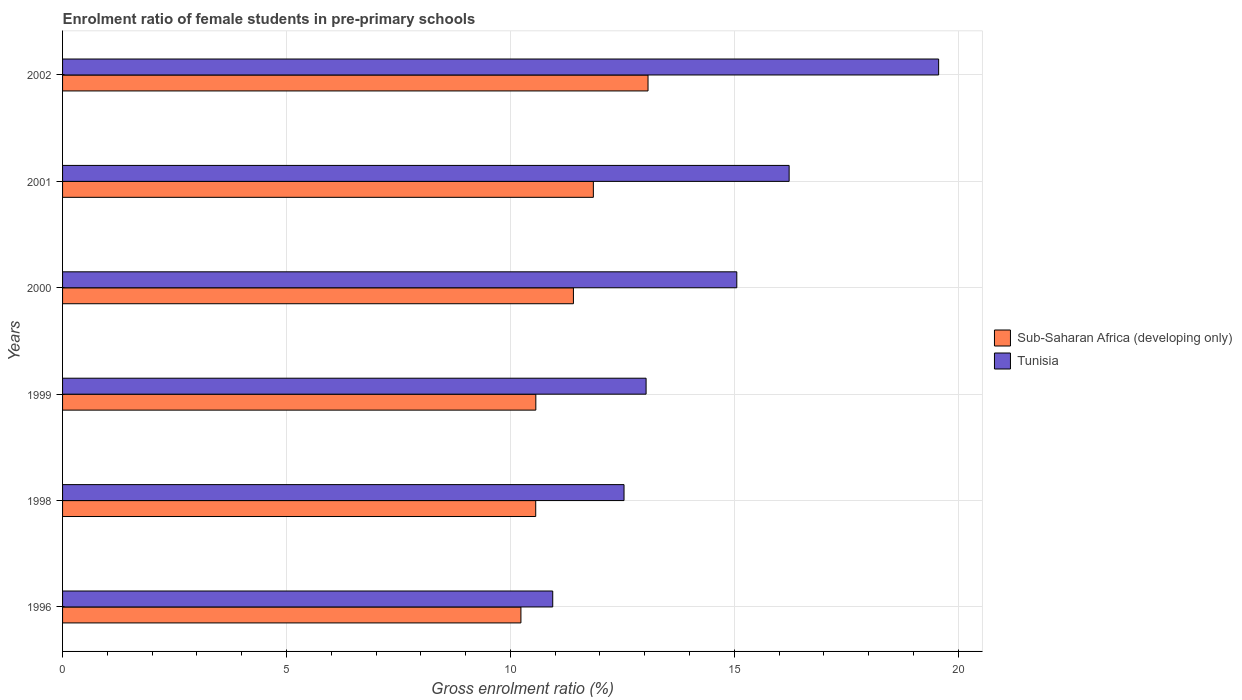How many groups of bars are there?
Offer a terse response. 6. Are the number of bars per tick equal to the number of legend labels?
Provide a succinct answer. Yes. What is the enrolment ratio of female students in pre-primary schools in Sub-Saharan Africa (developing only) in 2002?
Keep it short and to the point. 13.07. Across all years, what is the maximum enrolment ratio of female students in pre-primary schools in Tunisia?
Provide a succinct answer. 19.56. Across all years, what is the minimum enrolment ratio of female students in pre-primary schools in Tunisia?
Your response must be concise. 10.94. In which year was the enrolment ratio of female students in pre-primary schools in Tunisia maximum?
Your answer should be very brief. 2002. In which year was the enrolment ratio of female students in pre-primary schools in Tunisia minimum?
Keep it short and to the point. 1996. What is the total enrolment ratio of female students in pre-primary schools in Tunisia in the graph?
Your answer should be very brief. 87.35. What is the difference between the enrolment ratio of female students in pre-primary schools in Sub-Saharan Africa (developing only) in 1999 and that in 2002?
Offer a terse response. -2.51. What is the difference between the enrolment ratio of female students in pre-primary schools in Tunisia in 1996 and the enrolment ratio of female students in pre-primary schools in Sub-Saharan Africa (developing only) in 2002?
Offer a very short reply. -2.13. What is the average enrolment ratio of female students in pre-primary schools in Sub-Saharan Africa (developing only) per year?
Provide a succinct answer. 11.28. In the year 1996, what is the difference between the enrolment ratio of female students in pre-primary schools in Sub-Saharan Africa (developing only) and enrolment ratio of female students in pre-primary schools in Tunisia?
Keep it short and to the point. -0.71. In how many years, is the enrolment ratio of female students in pre-primary schools in Sub-Saharan Africa (developing only) greater than 15 %?
Provide a short and direct response. 0. What is the ratio of the enrolment ratio of female students in pre-primary schools in Sub-Saharan Africa (developing only) in 1996 to that in 2001?
Provide a short and direct response. 0.86. What is the difference between the highest and the second highest enrolment ratio of female students in pre-primary schools in Sub-Saharan Africa (developing only)?
Offer a very short reply. 1.22. What is the difference between the highest and the lowest enrolment ratio of female students in pre-primary schools in Tunisia?
Give a very brief answer. 8.62. What does the 1st bar from the top in 2000 represents?
Keep it short and to the point. Tunisia. What does the 1st bar from the bottom in 1996 represents?
Keep it short and to the point. Sub-Saharan Africa (developing only). How many bars are there?
Keep it short and to the point. 12. Are all the bars in the graph horizontal?
Ensure brevity in your answer.  Yes. How many years are there in the graph?
Your answer should be compact. 6. What is the difference between two consecutive major ticks on the X-axis?
Offer a terse response. 5. Does the graph contain any zero values?
Offer a very short reply. No. Where does the legend appear in the graph?
Your answer should be compact. Center right. What is the title of the graph?
Make the answer very short. Enrolment ratio of female students in pre-primary schools. Does "Kazakhstan" appear as one of the legend labels in the graph?
Offer a terse response. No. What is the Gross enrolment ratio (%) of Sub-Saharan Africa (developing only) in 1996?
Your response must be concise. 10.23. What is the Gross enrolment ratio (%) of Tunisia in 1996?
Give a very brief answer. 10.94. What is the Gross enrolment ratio (%) in Sub-Saharan Africa (developing only) in 1998?
Ensure brevity in your answer.  10.56. What is the Gross enrolment ratio (%) in Tunisia in 1998?
Your answer should be very brief. 12.54. What is the Gross enrolment ratio (%) of Sub-Saharan Africa (developing only) in 1999?
Make the answer very short. 10.57. What is the Gross enrolment ratio (%) of Tunisia in 1999?
Ensure brevity in your answer.  13.03. What is the Gross enrolment ratio (%) of Sub-Saharan Africa (developing only) in 2000?
Your response must be concise. 11.41. What is the Gross enrolment ratio (%) in Tunisia in 2000?
Provide a short and direct response. 15.05. What is the Gross enrolment ratio (%) in Sub-Saharan Africa (developing only) in 2001?
Make the answer very short. 11.85. What is the Gross enrolment ratio (%) in Tunisia in 2001?
Your answer should be very brief. 16.22. What is the Gross enrolment ratio (%) in Sub-Saharan Africa (developing only) in 2002?
Give a very brief answer. 13.07. What is the Gross enrolment ratio (%) in Tunisia in 2002?
Ensure brevity in your answer.  19.56. Across all years, what is the maximum Gross enrolment ratio (%) of Sub-Saharan Africa (developing only)?
Ensure brevity in your answer.  13.07. Across all years, what is the maximum Gross enrolment ratio (%) of Tunisia?
Offer a terse response. 19.56. Across all years, what is the minimum Gross enrolment ratio (%) of Sub-Saharan Africa (developing only)?
Offer a terse response. 10.23. Across all years, what is the minimum Gross enrolment ratio (%) in Tunisia?
Offer a very short reply. 10.94. What is the total Gross enrolment ratio (%) of Sub-Saharan Africa (developing only) in the graph?
Your answer should be very brief. 67.7. What is the total Gross enrolment ratio (%) of Tunisia in the graph?
Your answer should be very brief. 87.35. What is the difference between the Gross enrolment ratio (%) in Sub-Saharan Africa (developing only) in 1996 and that in 1998?
Your answer should be compact. -0.33. What is the difference between the Gross enrolment ratio (%) in Tunisia in 1996 and that in 1998?
Offer a terse response. -1.59. What is the difference between the Gross enrolment ratio (%) of Sub-Saharan Africa (developing only) in 1996 and that in 1999?
Ensure brevity in your answer.  -0.33. What is the difference between the Gross enrolment ratio (%) in Tunisia in 1996 and that in 1999?
Keep it short and to the point. -2.08. What is the difference between the Gross enrolment ratio (%) of Sub-Saharan Africa (developing only) in 1996 and that in 2000?
Ensure brevity in your answer.  -1.17. What is the difference between the Gross enrolment ratio (%) of Tunisia in 1996 and that in 2000?
Provide a succinct answer. -4.11. What is the difference between the Gross enrolment ratio (%) in Sub-Saharan Africa (developing only) in 1996 and that in 2001?
Provide a succinct answer. -1.62. What is the difference between the Gross enrolment ratio (%) of Tunisia in 1996 and that in 2001?
Provide a short and direct response. -5.28. What is the difference between the Gross enrolment ratio (%) in Sub-Saharan Africa (developing only) in 1996 and that in 2002?
Keep it short and to the point. -2.84. What is the difference between the Gross enrolment ratio (%) in Tunisia in 1996 and that in 2002?
Provide a short and direct response. -8.62. What is the difference between the Gross enrolment ratio (%) of Sub-Saharan Africa (developing only) in 1998 and that in 1999?
Provide a succinct answer. -0. What is the difference between the Gross enrolment ratio (%) of Tunisia in 1998 and that in 1999?
Your answer should be compact. -0.49. What is the difference between the Gross enrolment ratio (%) in Sub-Saharan Africa (developing only) in 1998 and that in 2000?
Your answer should be compact. -0.84. What is the difference between the Gross enrolment ratio (%) in Tunisia in 1998 and that in 2000?
Give a very brief answer. -2.52. What is the difference between the Gross enrolment ratio (%) in Sub-Saharan Africa (developing only) in 1998 and that in 2001?
Make the answer very short. -1.29. What is the difference between the Gross enrolment ratio (%) of Tunisia in 1998 and that in 2001?
Keep it short and to the point. -3.69. What is the difference between the Gross enrolment ratio (%) in Sub-Saharan Africa (developing only) in 1998 and that in 2002?
Offer a terse response. -2.51. What is the difference between the Gross enrolment ratio (%) in Tunisia in 1998 and that in 2002?
Offer a very short reply. -7.02. What is the difference between the Gross enrolment ratio (%) of Sub-Saharan Africa (developing only) in 1999 and that in 2000?
Ensure brevity in your answer.  -0.84. What is the difference between the Gross enrolment ratio (%) in Tunisia in 1999 and that in 2000?
Make the answer very short. -2.03. What is the difference between the Gross enrolment ratio (%) in Sub-Saharan Africa (developing only) in 1999 and that in 2001?
Make the answer very short. -1.28. What is the difference between the Gross enrolment ratio (%) in Tunisia in 1999 and that in 2001?
Offer a terse response. -3.19. What is the difference between the Gross enrolment ratio (%) of Sub-Saharan Africa (developing only) in 1999 and that in 2002?
Ensure brevity in your answer.  -2.51. What is the difference between the Gross enrolment ratio (%) in Tunisia in 1999 and that in 2002?
Provide a short and direct response. -6.53. What is the difference between the Gross enrolment ratio (%) in Sub-Saharan Africa (developing only) in 2000 and that in 2001?
Your response must be concise. -0.45. What is the difference between the Gross enrolment ratio (%) of Tunisia in 2000 and that in 2001?
Give a very brief answer. -1.17. What is the difference between the Gross enrolment ratio (%) in Sub-Saharan Africa (developing only) in 2000 and that in 2002?
Provide a short and direct response. -1.67. What is the difference between the Gross enrolment ratio (%) of Tunisia in 2000 and that in 2002?
Offer a very short reply. -4.51. What is the difference between the Gross enrolment ratio (%) in Sub-Saharan Africa (developing only) in 2001 and that in 2002?
Provide a short and direct response. -1.22. What is the difference between the Gross enrolment ratio (%) in Tunisia in 2001 and that in 2002?
Your response must be concise. -3.34. What is the difference between the Gross enrolment ratio (%) in Sub-Saharan Africa (developing only) in 1996 and the Gross enrolment ratio (%) in Tunisia in 1998?
Offer a very short reply. -2.3. What is the difference between the Gross enrolment ratio (%) of Sub-Saharan Africa (developing only) in 1996 and the Gross enrolment ratio (%) of Tunisia in 1999?
Your answer should be very brief. -2.79. What is the difference between the Gross enrolment ratio (%) in Sub-Saharan Africa (developing only) in 1996 and the Gross enrolment ratio (%) in Tunisia in 2000?
Offer a terse response. -4.82. What is the difference between the Gross enrolment ratio (%) of Sub-Saharan Africa (developing only) in 1996 and the Gross enrolment ratio (%) of Tunisia in 2001?
Offer a very short reply. -5.99. What is the difference between the Gross enrolment ratio (%) of Sub-Saharan Africa (developing only) in 1996 and the Gross enrolment ratio (%) of Tunisia in 2002?
Your response must be concise. -9.33. What is the difference between the Gross enrolment ratio (%) of Sub-Saharan Africa (developing only) in 1998 and the Gross enrolment ratio (%) of Tunisia in 1999?
Provide a succinct answer. -2.46. What is the difference between the Gross enrolment ratio (%) in Sub-Saharan Africa (developing only) in 1998 and the Gross enrolment ratio (%) in Tunisia in 2000?
Make the answer very short. -4.49. What is the difference between the Gross enrolment ratio (%) in Sub-Saharan Africa (developing only) in 1998 and the Gross enrolment ratio (%) in Tunisia in 2001?
Give a very brief answer. -5.66. What is the difference between the Gross enrolment ratio (%) in Sub-Saharan Africa (developing only) in 1998 and the Gross enrolment ratio (%) in Tunisia in 2002?
Your response must be concise. -9. What is the difference between the Gross enrolment ratio (%) of Sub-Saharan Africa (developing only) in 1999 and the Gross enrolment ratio (%) of Tunisia in 2000?
Provide a succinct answer. -4.49. What is the difference between the Gross enrolment ratio (%) in Sub-Saharan Africa (developing only) in 1999 and the Gross enrolment ratio (%) in Tunisia in 2001?
Offer a very short reply. -5.66. What is the difference between the Gross enrolment ratio (%) of Sub-Saharan Africa (developing only) in 1999 and the Gross enrolment ratio (%) of Tunisia in 2002?
Your answer should be compact. -8.99. What is the difference between the Gross enrolment ratio (%) in Sub-Saharan Africa (developing only) in 2000 and the Gross enrolment ratio (%) in Tunisia in 2001?
Ensure brevity in your answer.  -4.82. What is the difference between the Gross enrolment ratio (%) in Sub-Saharan Africa (developing only) in 2000 and the Gross enrolment ratio (%) in Tunisia in 2002?
Give a very brief answer. -8.15. What is the difference between the Gross enrolment ratio (%) of Sub-Saharan Africa (developing only) in 2001 and the Gross enrolment ratio (%) of Tunisia in 2002?
Offer a very short reply. -7.71. What is the average Gross enrolment ratio (%) in Sub-Saharan Africa (developing only) per year?
Offer a terse response. 11.28. What is the average Gross enrolment ratio (%) of Tunisia per year?
Your answer should be very brief. 14.56. In the year 1996, what is the difference between the Gross enrolment ratio (%) in Sub-Saharan Africa (developing only) and Gross enrolment ratio (%) in Tunisia?
Your answer should be very brief. -0.71. In the year 1998, what is the difference between the Gross enrolment ratio (%) of Sub-Saharan Africa (developing only) and Gross enrolment ratio (%) of Tunisia?
Keep it short and to the point. -1.97. In the year 1999, what is the difference between the Gross enrolment ratio (%) of Sub-Saharan Africa (developing only) and Gross enrolment ratio (%) of Tunisia?
Your response must be concise. -2.46. In the year 2000, what is the difference between the Gross enrolment ratio (%) in Sub-Saharan Africa (developing only) and Gross enrolment ratio (%) in Tunisia?
Give a very brief answer. -3.65. In the year 2001, what is the difference between the Gross enrolment ratio (%) of Sub-Saharan Africa (developing only) and Gross enrolment ratio (%) of Tunisia?
Your response must be concise. -4.37. In the year 2002, what is the difference between the Gross enrolment ratio (%) in Sub-Saharan Africa (developing only) and Gross enrolment ratio (%) in Tunisia?
Keep it short and to the point. -6.49. What is the ratio of the Gross enrolment ratio (%) in Sub-Saharan Africa (developing only) in 1996 to that in 1998?
Keep it short and to the point. 0.97. What is the ratio of the Gross enrolment ratio (%) in Tunisia in 1996 to that in 1998?
Offer a very short reply. 0.87. What is the ratio of the Gross enrolment ratio (%) of Sub-Saharan Africa (developing only) in 1996 to that in 1999?
Ensure brevity in your answer.  0.97. What is the ratio of the Gross enrolment ratio (%) in Tunisia in 1996 to that in 1999?
Your answer should be compact. 0.84. What is the ratio of the Gross enrolment ratio (%) in Sub-Saharan Africa (developing only) in 1996 to that in 2000?
Make the answer very short. 0.9. What is the ratio of the Gross enrolment ratio (%) in Tunisia in 1996 to that in 2000?
Your answer should be compact. 0.73. What is the ratio of the Gross enrolment ratio (%) in Sub-Saharan Africa (developing only) in 1996 to that in 2001?
Offer a terse response. 0.86. What is the ratio of the Gross enrolment ratio (%) in Tunisia in 1996 to that in 2001?
Your response must be concise. 0.67. What is the ratio of the Gross enrolment ratio (%) in Sub-Saharan Africa (developing only) in 1996 to that in 2002?
Your response must be concise. 0.78. What is the ratio of the Gross enrolment ratio (%) of Tunisia in 1996 to that in 2002?
Make the answer very short. 0.56. What is the ratio of the Gross enrolment ratio (%) of Tunisia in 1998 to that in 1999?
Your answer should be very brief. 0.96. What is the ratio of the Gross enrolment ratio (%) in Sub-Saharan Africa (developing only) in 1998 to that in 2000?
Provide a short and direct response. 0.93. What is the ratio of the Gross enrolment ratio (%) in Tunisia in 1998 to that in 2000?
Your answer should be compact. 0.83. What is the ratio of the Gross enrolment ratio (%) in Sub-Saharan Africa (developing only) in 1998 to that in 2001?
Your answer should be compact. 0.89. What is the ratio of the Gross enrolment ratio (%) of Tunisia in 1998 to that in 2001?
Your answer should be very brief. 0.77. What is the ratio of the Gross enrolment ratio (%) in Sub-Saharan Africa (developing only) in 1998 to that in 2002?
Make the answer very short. 0.81. What is the ratio of the Gross enrolment ratio (%) of Tunisia in 1998 to that in 2002?
Offer a terse response. 0.64. What is the ratio of the Gross enrolment ratio (%) in Sub-Saharan Africa (developing only) in 1999 to that in 2000?
Offer a terse response. 0.93. What is the ratio of the Gross enrolment ratio (%) of Tunisia in 1999 to that in 2000?
Keep it short and to the point. 0.87. What is the ratio of the Gross enrolment ratio (%) in Sub-Saharan Africa (developing only) in 1999 to that in 2001?
Provide a short and direct response. 0.89. What is the ratio of the Gross enrolment ratio (%) of Tunisia in 1999 to that in 2001?
Provide a succinct answer. 0.8. What is the ratio of the Gross enrolment ratio (%) in Sub-Saharan Africa (developing only) in 1999 to that in 2002?
Your answer should be very brief. 0.81. What is the ratio of the Gross enrolment ratio (%) of Tunisia in 1999 to that in 2002?
Your response must be concise. 0.67. What is the ratio of the Gross enrolment ratio (%) in Sub-Saharan Africa (developing only) in 2000 to that in 2001?
Offer a terse response. 0.96. What is the ratio of the Gross enrolment ratio (%) of Tunisia in 2000 to that in 2001?
Your answer should be very brief. 0.93. What is the ratio of the Gross enrolment ratio (%) of Sub-Saharan Africa (developing only) in 2000 to that in 2002?
Your answer should be compact. 0.87. What is the ratio of the Gross enrolment ratio (%) of Tunisia in 2000 to that in 2002?
Provide a short and direct response. 0.77. What is the ratio of the Gross enrolment ratio (%) in Sub-Saharan Africa (developing only) in 2001 to that in 2002?
Your answer should be compact. 0.91. What is the ratio of the Gross enrolment ratio (%) of Tunisia in 2001 to that in 2002?
Provide a succinct answer. 0.83. What is the difference between the highest and the second highest Gross enrolment ratio (%) of Sub-Saharan Africa (developing only)?
Offer a very short reply. 1.22. What is the difference between the highest and the second highest Gross enrolment ratio (%) of Tunisia?
Keep it short and to the point. 3.34. What is the difference between the highest and the lowest Gross enrolment ratio (%) of Sub-Saharan Africa (developing only)?
Keep it short and to the point. 2.84. What is the difference between the highest and the lowest Gross enrolment ratio (%) of Tunisia?
Keep it short and to the point. 8.62. 